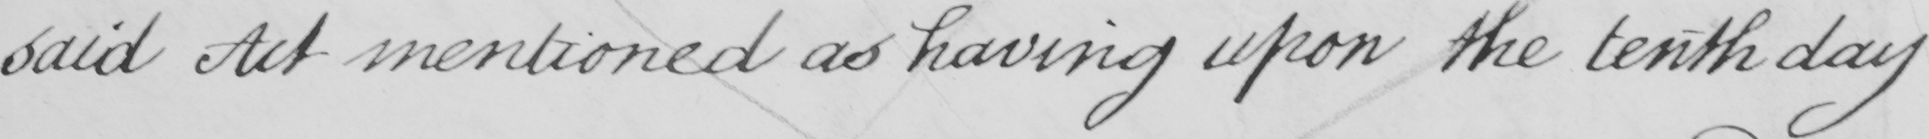Can you tell me what this handwritten text says? said Act mentioned as having upon the tenth day 